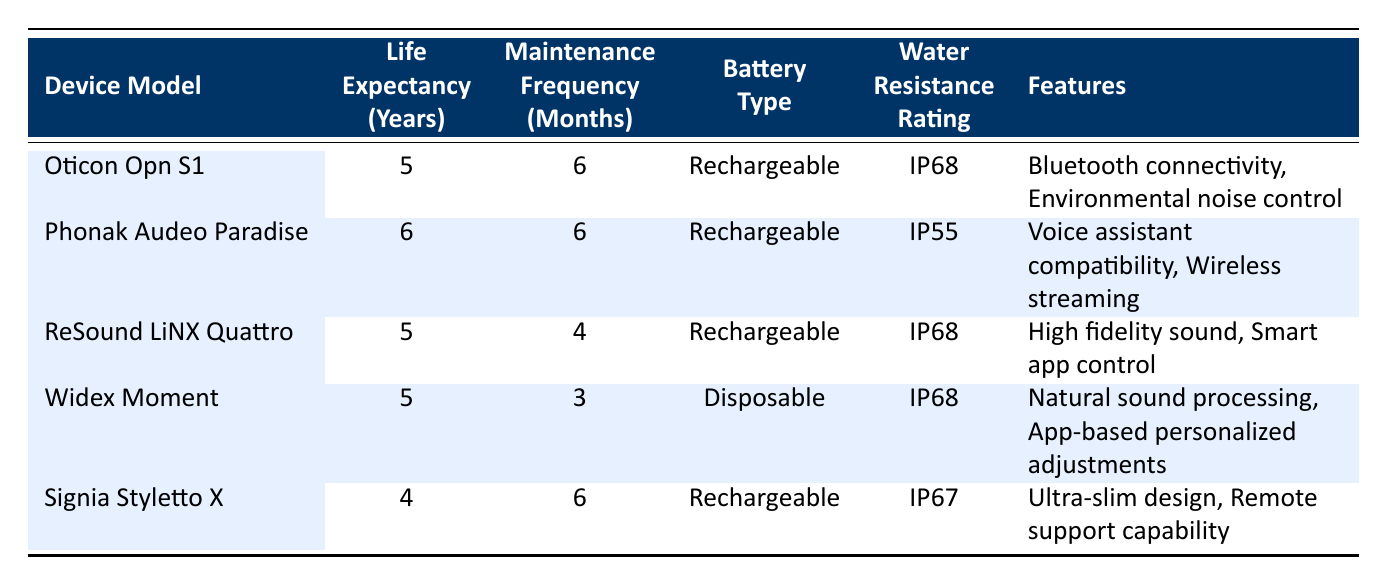What is the life expectancy of the Phonak Audeo Paradise? The table shows the life expectancy of the Phonak Audeo Paradise in the respective column, which is stated as 6 years.
Answer: 6 years Which device has the shortest life expectancy? By comparing the life expectancy years across all devices in the table, the Signia Styletto X has the shortest life expectancy of 4 years.
Answer: Signia Styletto X How many months of maintenance frequency does the Widex Moment require? The table provides the maintenance frequency for the Widex Moment, listed as 3 months.
Answer: 3 months Does the Oticon Opn S1 have a rechargeable battery? The details for the Oticon Opn S1 in the table include the battery type being labeled as rechargeable, confirming the information.
Answer: Yes What is the average life expectancy of the hearing aids listed? To find the average life expectancy, sum the life expectancies (5+6+5+5+4) = 25 years, then divide by 5 (the number of devices), thus 25/5 = 5 years.
Answer: 5 years Is the water resistance rating of the Phonak Audeo Paradise higher than the Oticon Opn S1? The table shows that the Phonak Audeo Paradise has a water resistance rating of IP55 while the Oticon Opn S1 has IP68, indicating that Phonak's rating is lower.
Answer: No Which hearing aid device requires maintenance more frequently than every 4 months? By checking the maintenance frequency column, both the Oticon Opn S1 and Phonak Audeo Paradise have a current maintenance frequency of 6 months, and the Widex Moment has 3 months, indicating they require maintenance every 3 or 6 months, which is more frequent than every 4 months.
Answer: Oticon Opn S1, Phonak Audeo Paradise, and Widex Moment Are any of the devices water-resistant with a rating of IP68? The table lists both the Oticon Opn S1, ReSound LiNX Quattro, and Widex Moment as having a water resistance rating of IP68, confirming that they are indeed water-resistant at that level.
Answer: Yes Which model has voice assistant compatibility among the features? Looking at the features listed, only the Phonak Audeo Paradise includes voice assistant compatibility as a feature.
Answer: Phonak Audeo Paradise What is the difference in life expectancy between the ReSound LiNX Quattro and the Signia Styletto X? The life expectancy of the ReSound LiNX Quattro is 5 years and that of the Signia Styletto X is 4 years, thus the difference is 5 - 4 = 1 year.
Answer: 1 year 